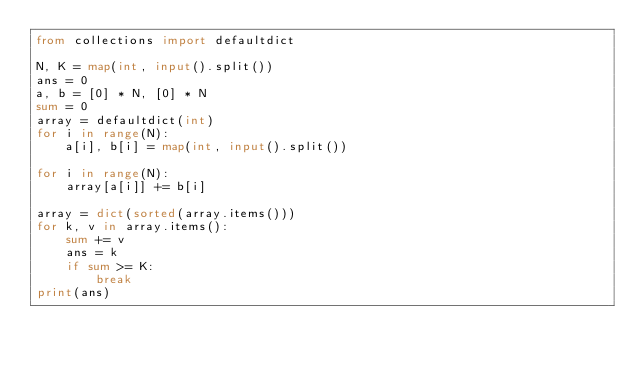<code> <loc_0><loc_0><loc_500><loc_500><_Python_>from collections import defaultdict

N, K = map(int, input().split())
ans = 0
a, b = [0] * N, [0] * N
sum = 0
array = defaultdict(int)
for i in range(N):
    a[i], b[i] = map(int, input().split())

for i in range(N):
    array[a[i]] += b[i]

array = dict(sorted(array.items()))
for k, v in array.items():
    sum += v
    ans = k
    if sum >= K:
        break
print(ans)</code> 